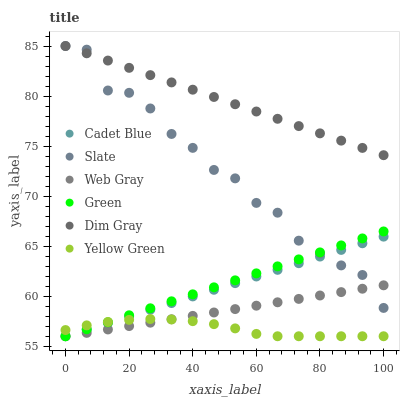Does Yellow Green have the minimum area under the curve?
Answer yes or no. Yes. Does Dim Gray have the maximum area under the curve?
Answer yes or no. Yes. Does Slate have the minimum area under the curve?
Answer yes or no. No. Does Slate have the maximum area under the curve?
Answer yes or no. No. Is Green the smoothest?
Answer yes or no. Yes. Is Slate the roughest?
Answer yes or no. Yes. Is Yellow Green the smoothest?
Answer yes or no. No. Is Yellow Green the roughest?
Answer yes or no. No. Does Cadet Blue have the lowest value?
Answer yes or no. Yes. Does Slate have the lowest value?
Answer yes or no. No. Does Dim Gray have the highest value?
Answer yes or no. Yes. Does Yellow Green have the highest value?
Answer yes or no. No. Is Web Gray less than Dim Gray?
Answer yes or no. Yes. Is Dim Gray greater than Yellow Green?
Answer yes or no. Yes. Does Green intersect Web Gray?
Answer yes or no. Yes. Is Green less than Web Gray?
Answer yes or no. No. Is Green greater than Web Gray?
Answer yes or no. No. Does Web Gray intersect Dim Gray?
Answer yes or no. No. 